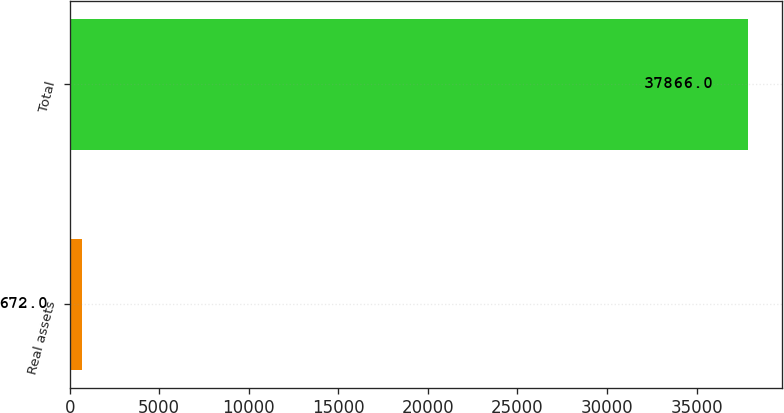<chart> <loc_0><loc_0><loc_500><loc_500><bar_chart><fcel>Real assets<fcel>Total<nl><fcel>672<fcel>37866<nl></chart> 